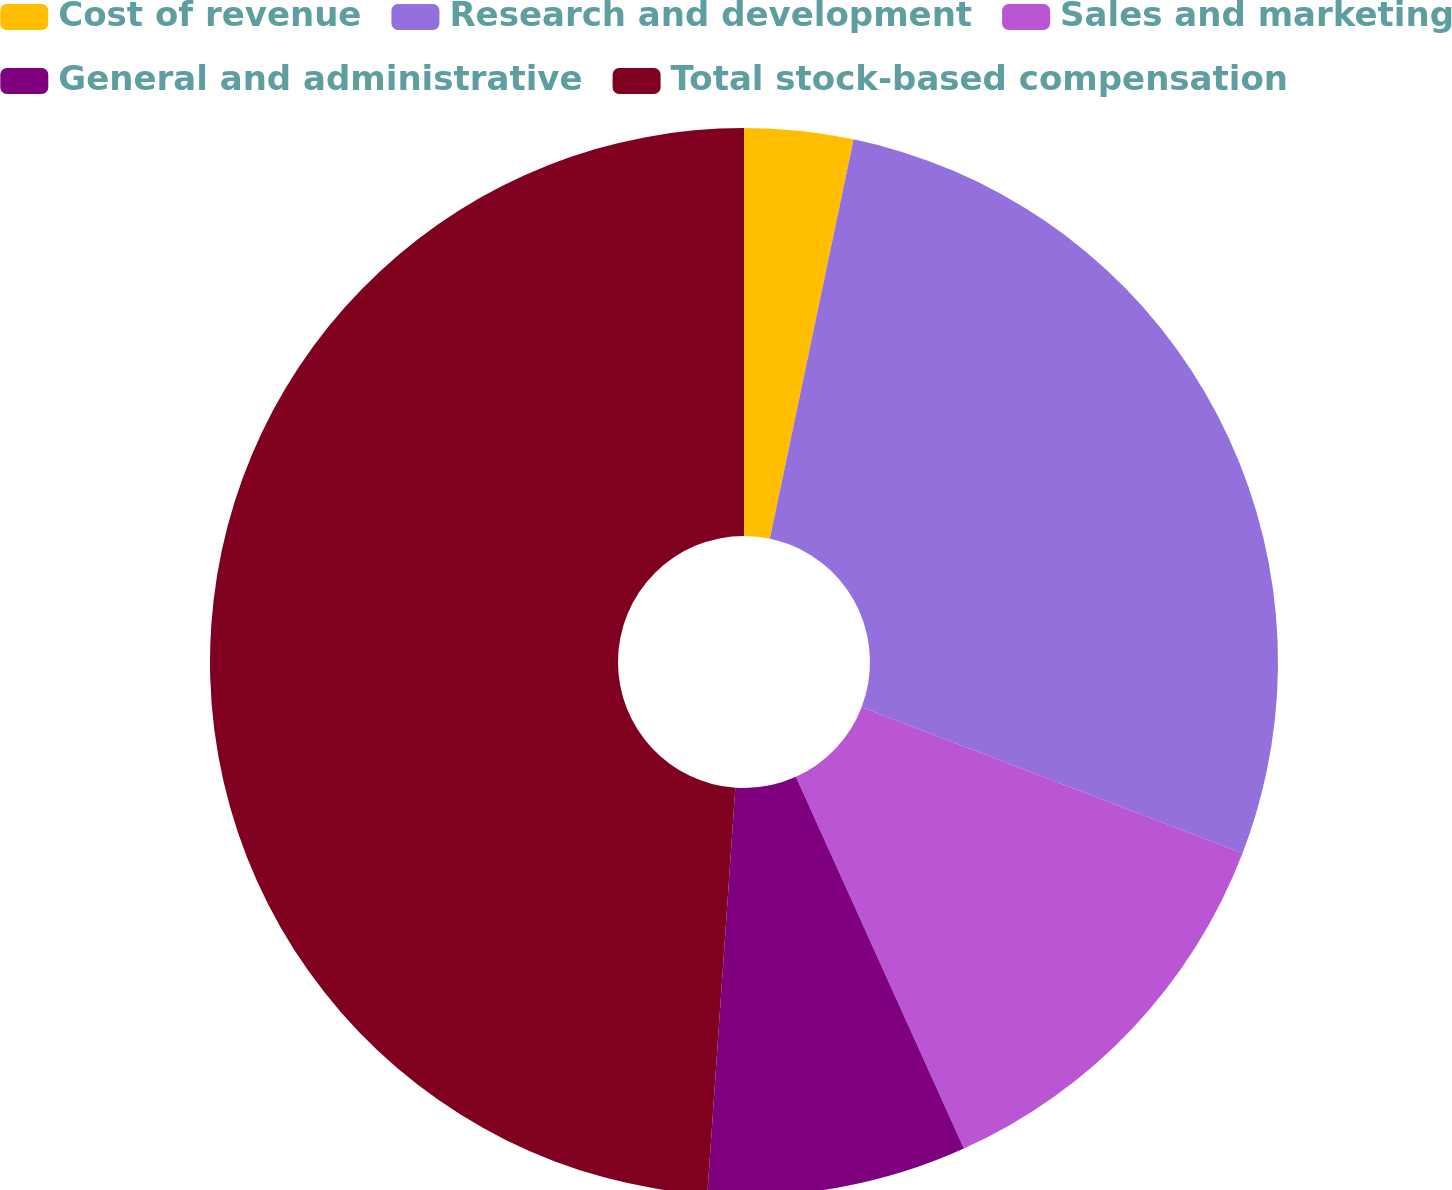Convert chart. <chart><loc_0><loc_0><loc_500><loc_500><pie_chart><fcel>Cost of revenue<fcel>Research and development<fcel>Sales and marketing<fcel>General and administrative<fcel>Total stock-based compensation<nl><fcel>3.29%<fcel>27.54%<fcel>12.41%<fcel>7.85%<fcel>48.9%<nl></chart> 